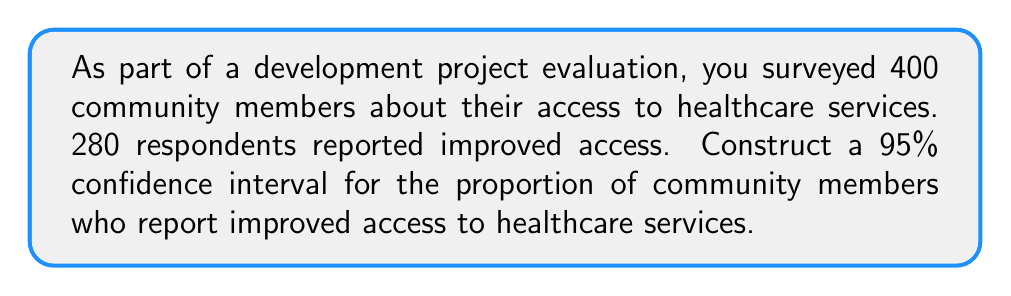Solve this math problem. Let's construct the confidence interval step-by-step:

1) First, calculate the sample proportion $\hat{p}$:
   $$\hat{p} = \frac{280}{400} = 0.7$$

2) The formula for the confidence interval is:
   $$\hat{p} \pm z^* \sqrt{\frac{\hat{p}(1-\hat{p})}{n}}$$
   where $z^*$ is the critical value for the desired confidence level.

3) For a 95% confidence interval, $z^* = 1.96$.

4) Calculate the standard error:
   $$SE = \sqrt{\frac{\hat{p}(1-\hat{p})}{n}} = \sqrt{\frac{0.7(1-0.7)}{400}} = 0.0229$$

5) Now, we can calculate the margin of error:
   $$ME = z^* \times SE = 1.96 \times 0.0229 = 0.0449$$

6) Finally, construct the confidence interval:
   $$0.7 \pm 0.0449$$

   Lower bound: $0.7 - 0.0449 = 0.6551$
   Upper bound: $0.7 + 0.0449 = 0.7449$

Therefore, we are 95% confident that the true proportion of community members who report improved access to healthcare services is between 0.6551 and 0.7449, or between 65.51% and 74.49%.
Answer: (0.6551, 0.7449) 